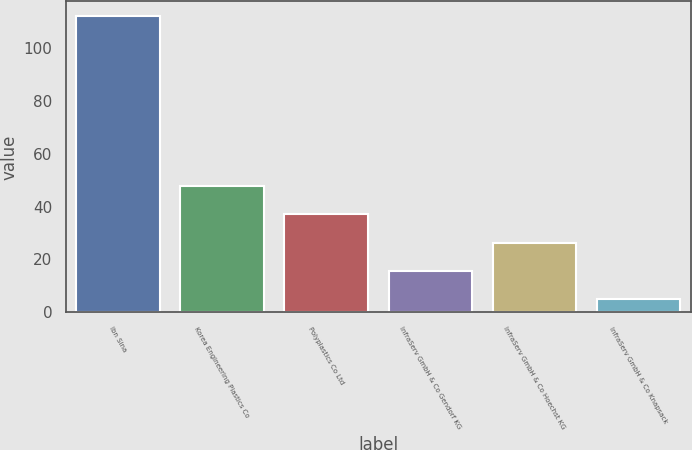Convert chart. <chart><loc_0><loc_0><loc_500><loc_500><bar_chart><fcel>Ibn Sina<fcel>Korea Engineering Plastics Co<fcel>Polyplastics Co Ltd<fcel>InfraServ GmbH & Co Gendorf KG<fcel>InfraServ GmbH & Co Hoechst KG<fcel>InfraServ GmbH & Co Knapsack<nl><fcel>112<fcel>47.8<fcel>37.1<fcel>15.7<fcel>26.4<fcel>5<nl></chart> 